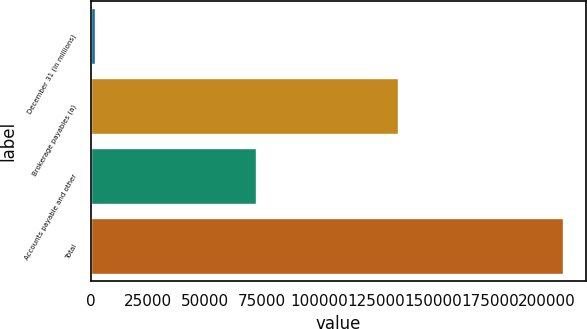<chart> <loc_0><loc_0><loc_500><loc_500><bar_chart><fcel>December 31 (in millions)<fcel>Brokerage payables (a)<fcel>Accounts payable and other<fcel>Total<nl><fcel>2014<fcel>134467<fcel>72472<fcel>206939<nl></chart> 